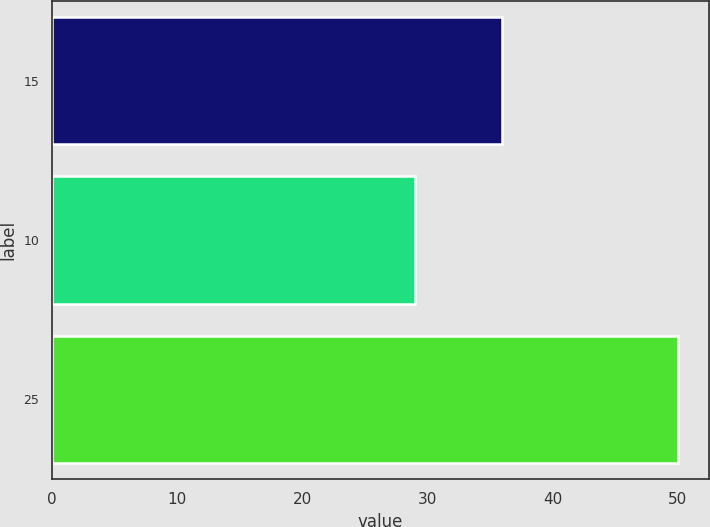Convert chart to OTSL. <chart><loc_0><loc_0><loc_500><loc_500><bar_chart><fcel>15<fcel>10<fcel>25<nl><fcel>36<fcel>29<fcel>50<nl></chart> 